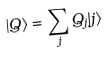<formula> <loc_0><loc_0><loc_500><loc_500>| Q \rangle = \sum _ { j } Q _ { j } | j \rangle</formula> 